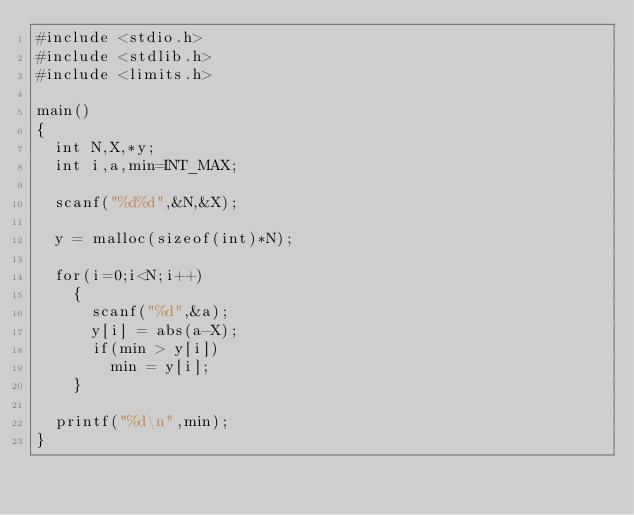Convert code to text. <code><loc_0><loc_0><loc_500><loc_500><_C_>#include <stdio.h>
#include <stdlib.h>
#include <limits.h>

main()
{
  int N,X,*y;
  int i,a,min=INT_MAX;

  scanf("%d%d",&N,&X);

  y = malloc(sizeof(int)*N);

  for(i=0;i<N;i++)
    {
      scanf("%d",&a);
      y[i] = abs(a-X);
      if(min > y[i])
        min = y[i];
    }

  printf("%d\n",min);
}
</code> 